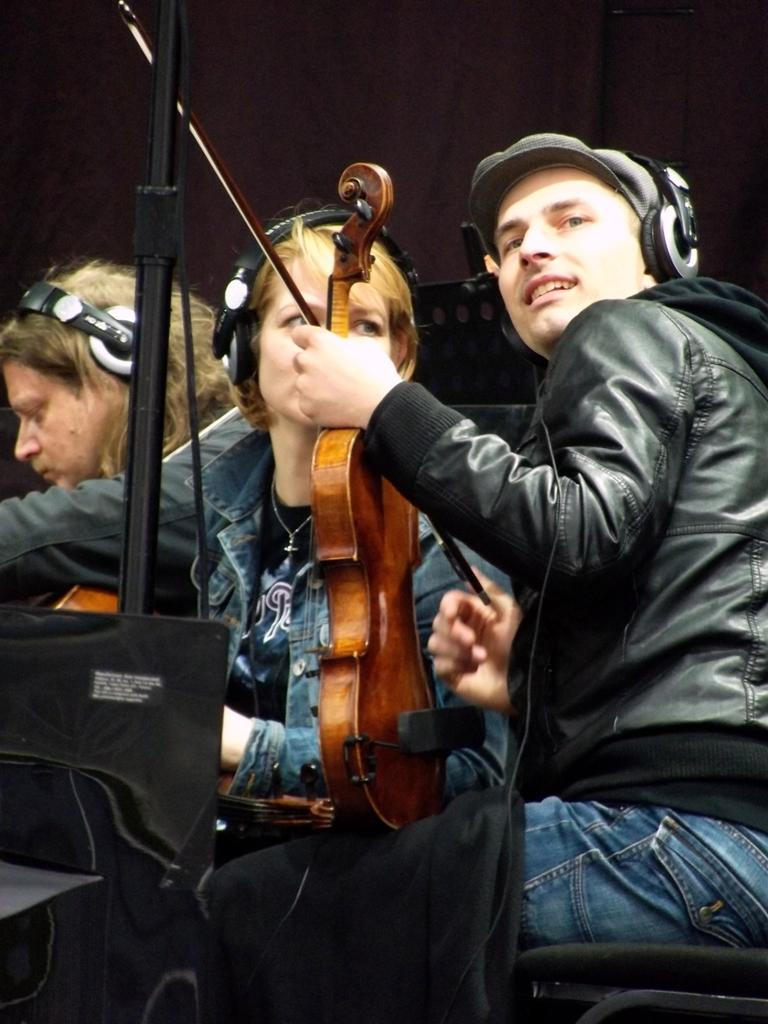How many people are in the image? There are three persons in the image. What are the persons holding in the image? Each person is holding a guitar. What are the persons wearing on their heads? The persons are wearing headsets. What is in front of the persons? There is a stand in front of the persons. What else can be seen in the image? Cables are present in the image. What type of button can be seen causing destruction in the image? There is no button or destruction present in the image. Can you see any sparks coming from the guitar strings in the image? There is no indication of sparks or any electrical activity in the image. 